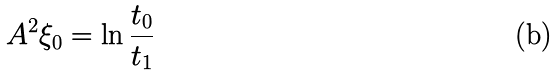Convert formula to latex. <formula><loc_0><loc_0><loc_500><loc_500>A ^ { 2 } \xi _ { 0 } = \ln \frac { t _ { 0 } } { t _ { 1 } }</formula> 